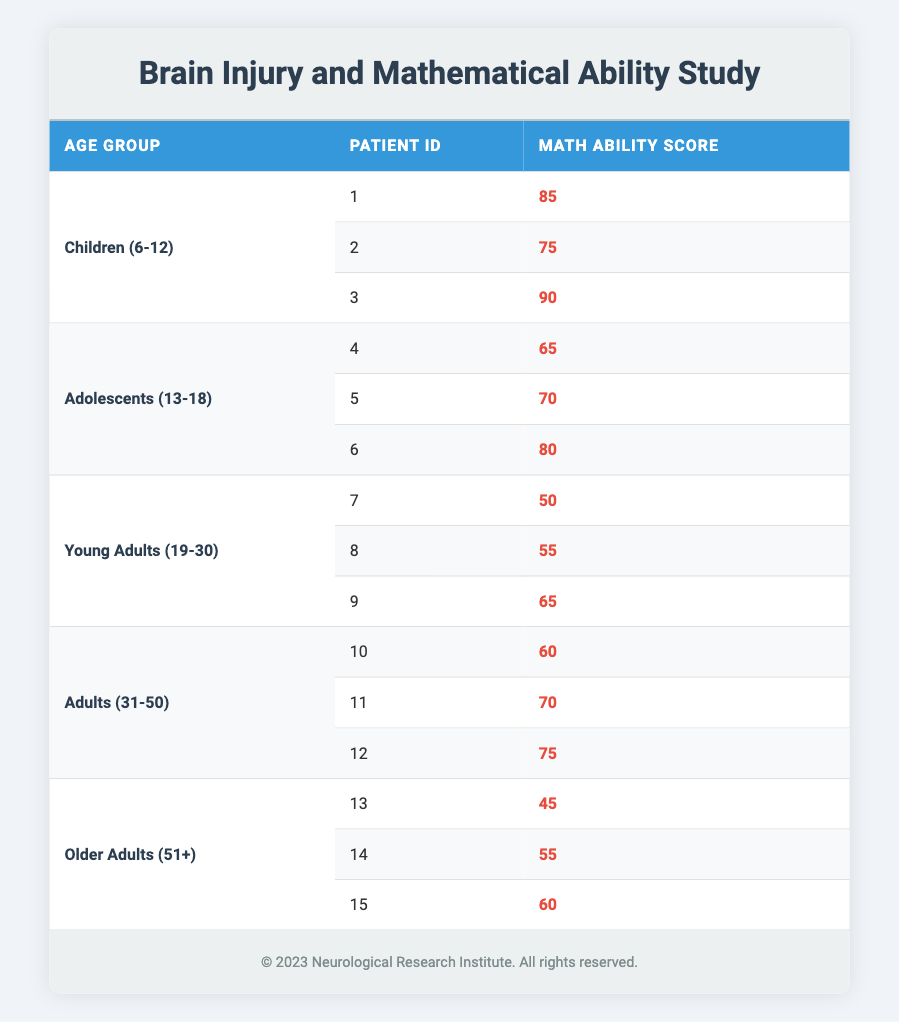What is the highest math ability score among the children aged 6-12? In the Children (6-12) age group, the math ability scores are 85, 75, and 90. The highest score is 90.
Answer: 90 What is the average math ability score for the Adolescents (13-18) age group? The math ability scores for Adolescents are 65, 70, and 80. The sum is 65 + 70 + 80 = 215. There are 3 patients, so the average is 215/3 ≈ 71.67.
Answer: 71.67 Are there any patients in the Young Adults (19-30) age group with a math ability score above 60? The math ability scores for Young Adults are 50, 55, and 65. Only one patient (ID 9) has a score above 60.
Answer: Yes What is the lowest math ability score recorded in the table? The lowest score among all age groups can be found by looking through all the scores: 85, 75, 90 (Children); 65, 70, 80 (Adolescents); 50, 55, 65 (Young Adults); 60, 70, 75 (Adults); 45, 55, 60 (Older Adults). The lowest score is 45.
Answer: 45 What is the difference between the average math ability scores of Children (6-12) and Older Adults (51+)? The average score for Children is (85 + 75 + 90) / 3 = 83.33. The average for Older Adults is (45 + 55 + 60) / 3 = 53.33. The difference is 83.33 - 53.33 = 30.
Answer: 30 How many patients fall into the Adult (31-50) age group? In the Adult (31-50) age group, there are three patients listed with IDs 10, 11, and 12.
Answer: 3 Is the average math ability score of Young Adults (19-30) greater than that of Adolescents (13-18)? The average score for Young Adults is (50 + 55 + 65) / 3 = 56.67, and for Adolescents, it is 71.67. Since 56.67 is not greater than 71.67, the answer is no.
Answer: No What is the sum of all math ability scores for patients aged 51 and above? The math ability scores for Older Adults (51+) are 45, 55, and 60. The sum is 45 + 55 + 60 = 160.
Answer: 160 What percentage of the total score does the highest score in the Children (6-12) age group represent? The highest score is 90. The total score for all patients is (85 + 75 + 90 + 65 + 70 + 80 + 50 + 55 + 65 + 60 + 70 + 75 + 45 + 55 + 60) = 1,020. The percentage is (90 / 1,020) * 100 ≈ 8.82%.
Answer: 8.82% 